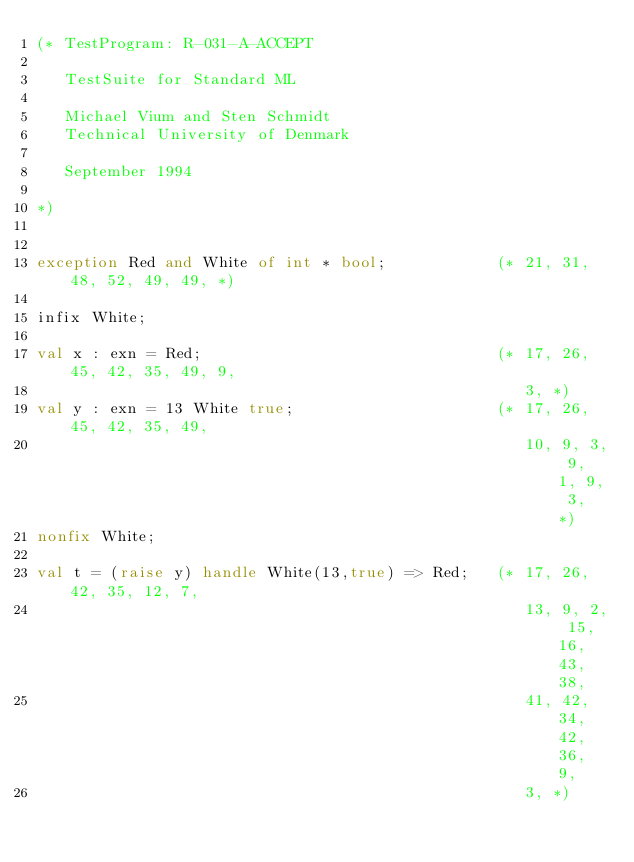<code> <loc_0><loc_0><loc_500><loc_500><_SML_>(* TestProgram: R-031-A-ACCEPT

   TestSuite for Standard ML

   Michael Vium and Sten Schmidt
   Technical University of Denmark

   September 1994

*)


exception Red and White of int * bool;            (* 21, 31, 48, 52, 49, 49, *)

infix White;

val x : exn = Red;                                (* 17, 26, 45, 42, 35, 49, 9,
                                                     3, *)
val y : exn = 13 White true;                      (* 17, 26, 45, 42, 35, 49,
                                                     10, 9, 3, 9, 1, 9, 3, *)
nonfix White;

val t = (raise y) handle White(13,true) => Red;   (* 17, 26, 42, 35, 12, 7,
                                                     13, 9, 2, 15, 16, 43, 38,
                                                     41, 42, 34, 42, 36, 9,
                                                     3, *)

</code> 